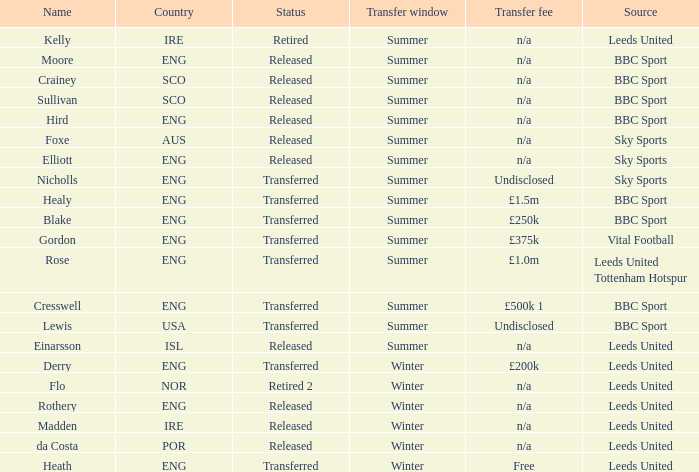From where did an eng transfer that paid a £ BBC Sport. 